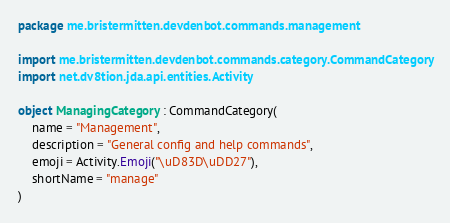Convert code to text. <code><loc_0><loc_0><loc_500><loc_500><_Kotlin_>package me.bristermitten.devdenbot.commands.management

import me.bristermitten.devdenbot.commands.category.CommandCategory
import net.dv8tion.jda.api.entities.Activity

object ManagingCategory : CommandCategory(
    name = "Management",
    description = "General config and help commands",
    emoji = Activity.Emoji("\uD83D\uDD27"),
    shortName = "manage"
)
</code> 